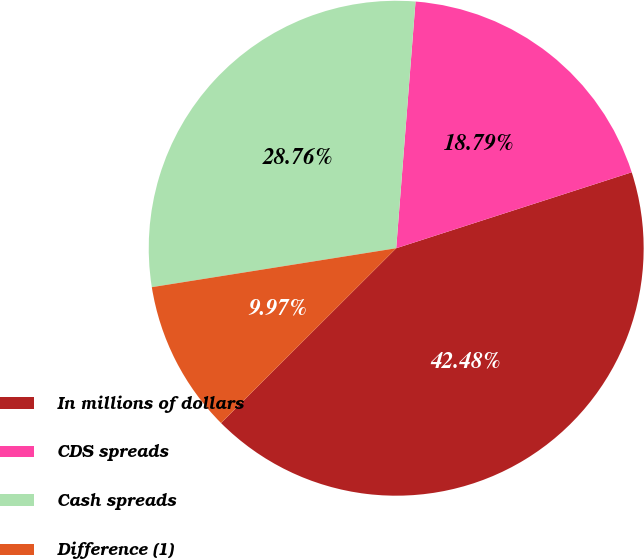<chart> <loc_0><loc_0><loc_500><loc_500><pie_chart><fcel>In millions of dollars<fcel>CDS spreads<fcel>Cash spreads<fcel>Difference (1)<nl><fcel>42.48%<fcel>18.79%<fcel>28.76%<fcel>9.97%<nl></chart> 